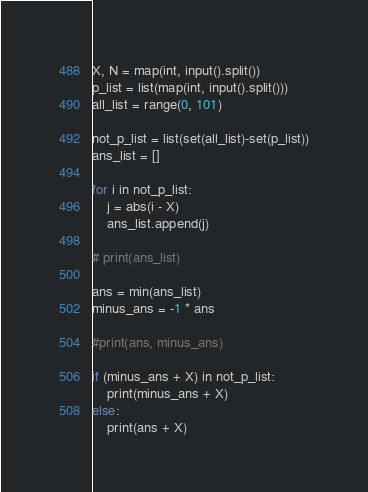<code> <loc_0><loc_0><loc_500><loc_500><_Python_>X, N = map(int, input().split())
p_list = list(map(int, input().split()))
all_list = range(0, 101)

not_p_list = list(set(all_list)-set(p_list))
ans_list = []

for i in not_p_list:
    j = abs(i - X)
    ans_list.append(j)

# print(ans_list)

ans = min(ans_list)
minus_ans = -1 * ans

#print(ans, minus_ans)

if (minus_ans + X) in not_p_list:
    print(minus_ans + X)
else:
    print(ans + X)
</code> 